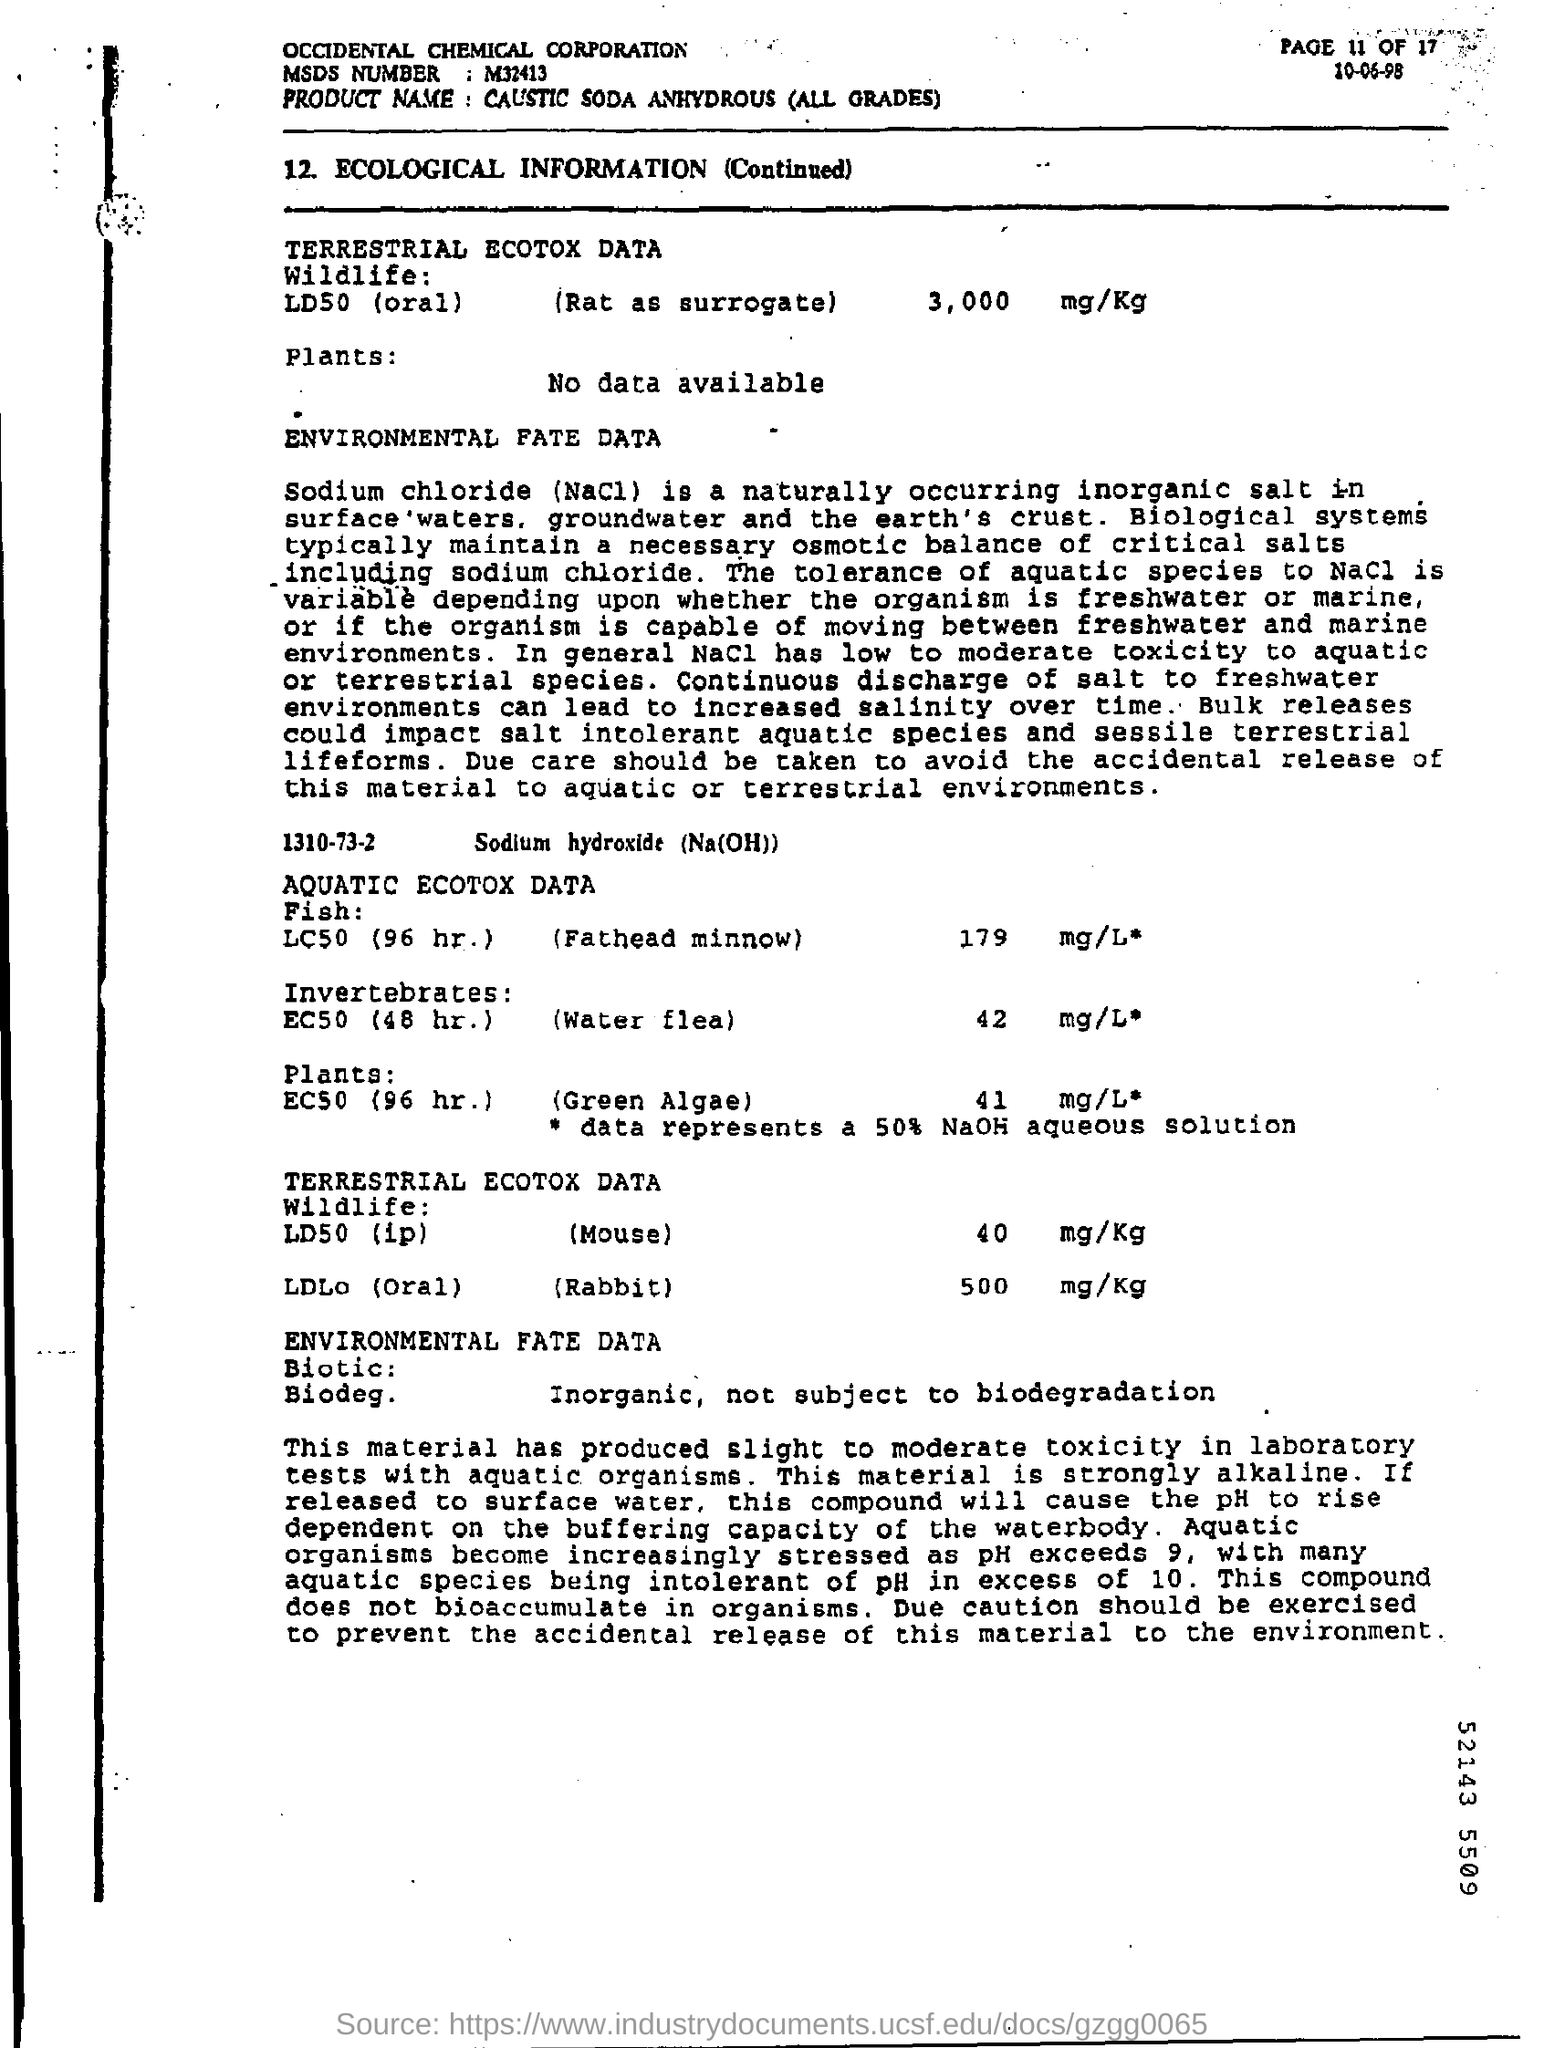What is the MSDS Number?
Keep it short and to the point. M32413. What is the Product Name?
Make the answer very short. Caustic Soda Anhydrous (All Grades). 